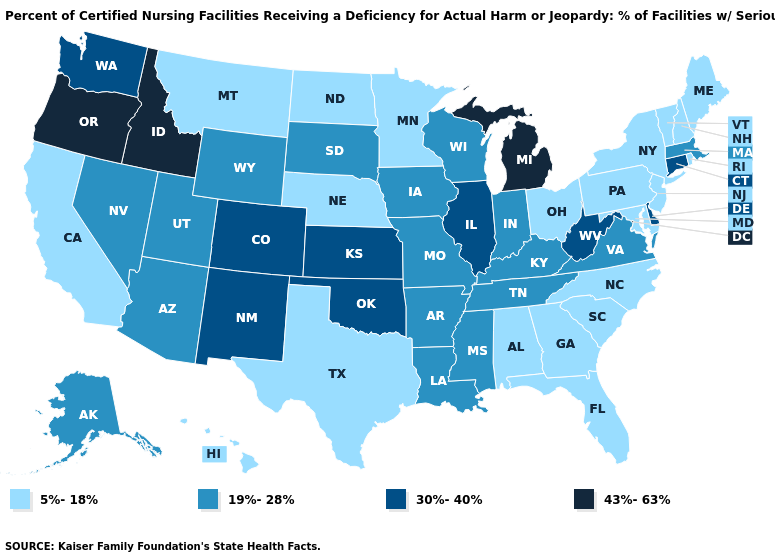Name the states that have a value in the range 30%-40%?
Concise answer only. Colorado, Connecticut, Delaware, Illinois, Kansas, New Mexico, Oklahoma, Washington, West Virginia. Does New Mexico have the highest value in the West?
Write a very short answer. No. Among the states that border Idaho , does Wyoming have the highest value?
Be succinct. No. Which states have the lowest value in the USA?
Be succinct. Alabama, California, Florida, Georgia, Hawaii, Maine, Maryland, Minnesota, Montana, Nebraska, New Hampshire, New Jersey, New York, North Carolina, North Dakota, Ohio, Pennsylvania, Rhode Island, South Carolina, Texas, Vermont. Name the states that have a value in the range 30%-40%?
Be succinct. Colorado, Connecticut, Delaware, Illinois, Kansas, New Mexico, Oklahoma, Washington, West Virginia. What is the value of North Carolina?
Be succinct. 5%-18%. Does Wyoming have the lowest value in the USA?
Quick response, please. No. Which states have the lowest value in the USA?
Short answer required. Alabama, California, Florida, Georgia, Hawaii, Maine, Maryland, Minnesota, Montana, Nebraska, New Hampshire, New Jersey, New York, North Carolina, North Dakota, Ohio, Pennsylvania, Rhode Island, South Carolina, Texas, Vermont. What is the highest value in the MidWest ?
Quick response, please. 43%-63%. Name the states that have a value in the range 19%-28%?
Be succinct. Alaska, Arizona, Arkansas, Indiana, Iowa, Kentucky, Louisiana, Massachusetts, Mississippi, Missouri, Nevada, South Dakota, Tennessee, Utah, Virginia, Wisconsin, Wyoming. What is the value of Ohio?
Keep it brief. 5%-18%. Which states hav the highest value in the Northeast?
Write a very short answer. Connecticut. What is the value of Connecticut?
Concise answer only. 30%-40%. What is the lowest value in the USA?
Short answer required. 5%-18%. Which states have the highest value in the USA?
Quick response, please. Idaho, Michigan, Oregon. 